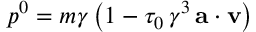<formula> <loc_0><loc_0><loc_500><loc_500>p ^ { 0 } = m \gamma \, \left ( 1 - \tau _ { 0 } \, \gamma ^ { 3 } \, { a } \cdot { v } \right )</formula> 